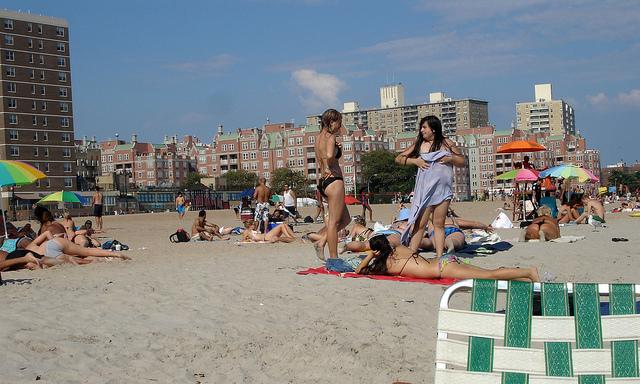The person under the orange umbrella is whom? Please explain your reasoning. life guard. They are up on a platform so they can see people in the water easier 